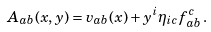<formula> <loc_0><loc_0><loc_500><loc_500>A _ { a b } ( x , y ) = v _ { a b } ( x ) + y ^ { i } \eta _ { i c } f _ { a b } ^ { c } \, .</formula> 